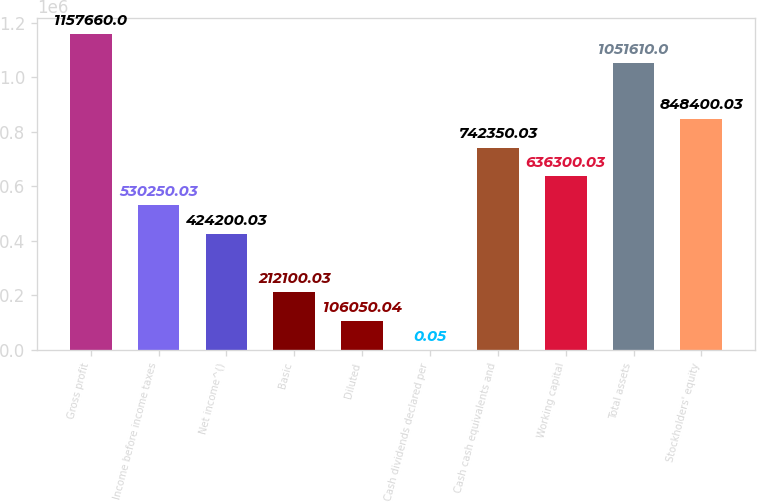Convert chart. <chart><loc_0><loc_0><loc_500><loc_500><bar_chart><fcel>Gross profit<fcel>Income before income taxes<fcel>Net income^()<fcel>Basic<fcel>Diluted<fcel>Cash dividends declared per<fcel>Cash cash equivalents and<fcel>Working capital<fcel>Total assets<fcel>Stockholders' equity<nl><fcel>1.15766e+06<fcel>530250<fcel>424200<fcel>212100<fcel>106050<fcel>0.05<fcel>742350<fcel>636300<fcel>1.05161e+06<fcel>848400<nl></chart> 